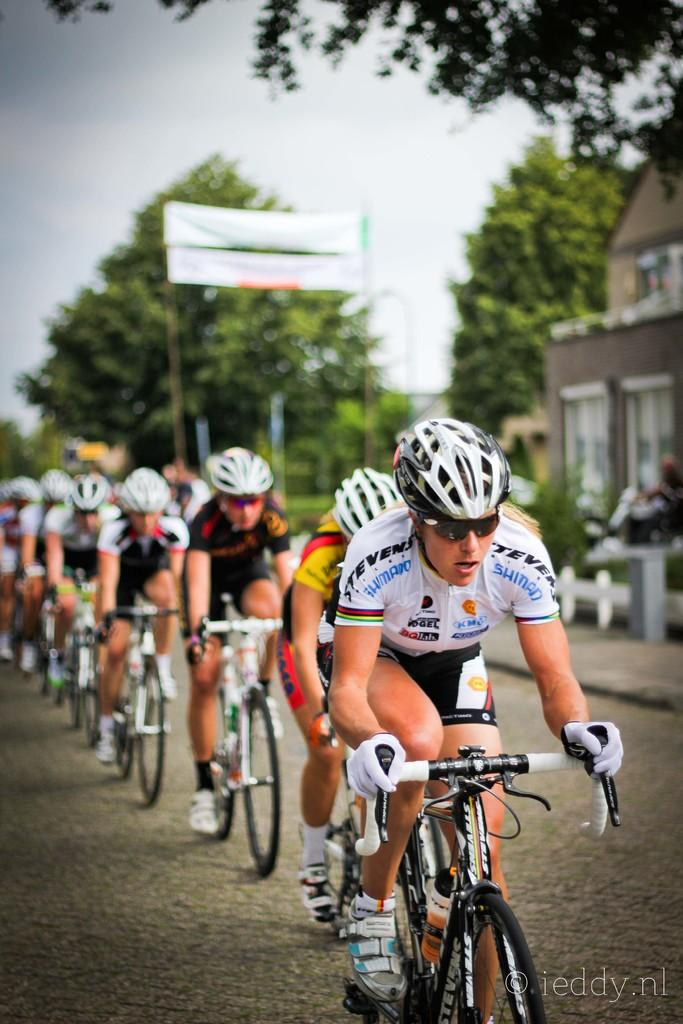How many people are in the image? There is a group of people in the image. What are the people doing in the image? The people are riding a bicycle. Where is the bicycle located in the image? The bicycle is in the road. What can be seen in the background of the image? There is a banner, a tree, a house, and the sky visible in the background of the image. What color is the daughter's bedroom in the image? There is no mention of a daughter or a bedroom in the image; it features a group of people riding a bicycle in the road. 